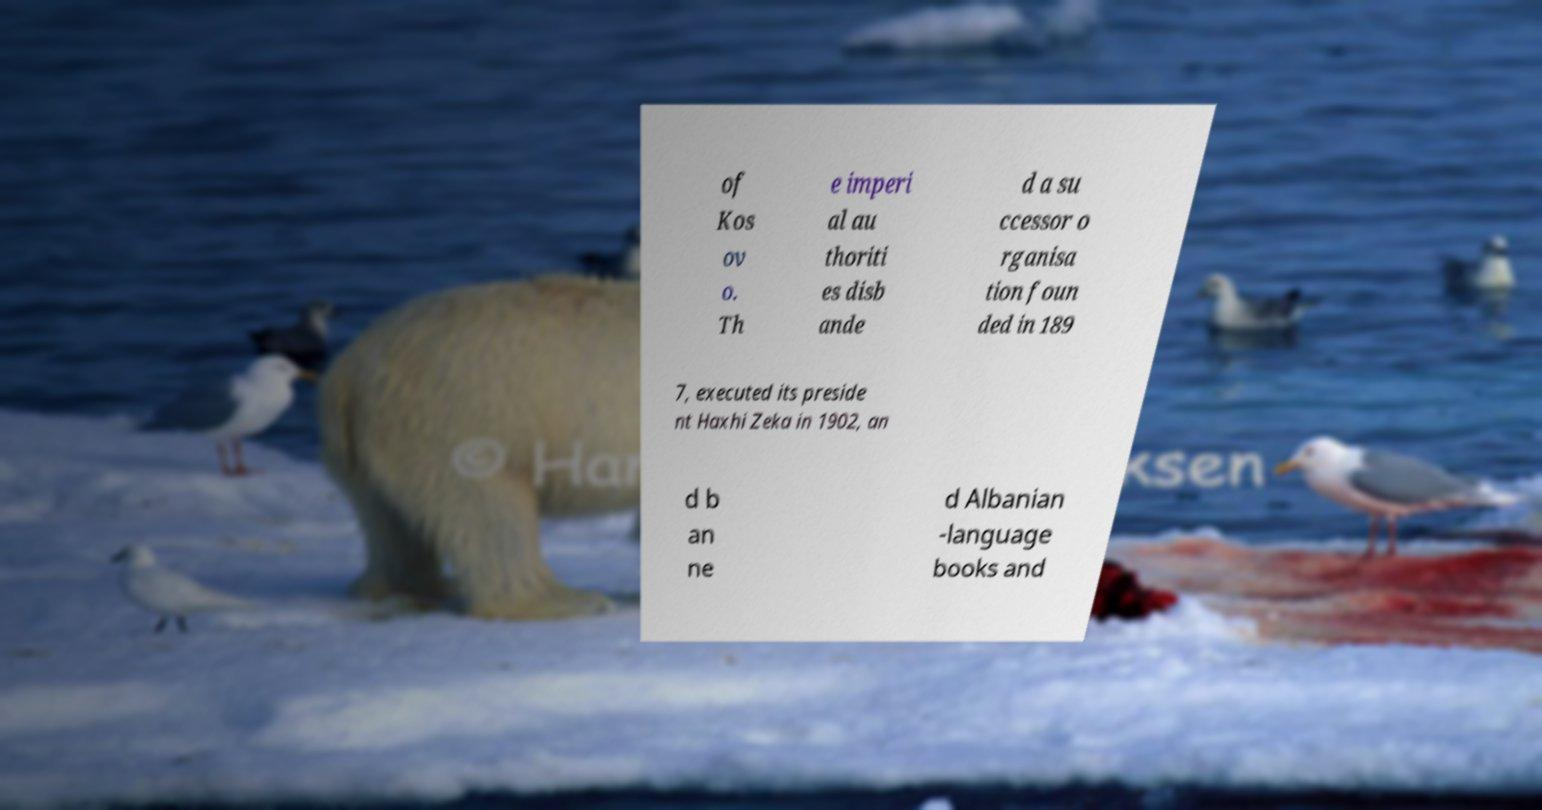Could you extract and type out the text from this image? of Kos ov o. Th e imperi al au thoriti es disb ande d a su ccessor o rganisa tion foun ded in 189 7, executed its preside nt Haxhi Zeka in 1902, an d b an ne d Albanian -language books and 